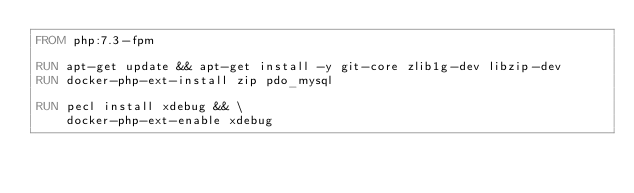<code> <loc_0><loc_0><loc_500><loc_500><_Dockerfile_>FROM php:7.3-fpm

RUN apt-get update && apt-get install -y git-core zlib1g-dev libzip-dev
RUN docker-php-ext-install zip pdo_mysql

RUN pecl install xdebug && \
    docker-php-ext-enable xdebug

</code> 